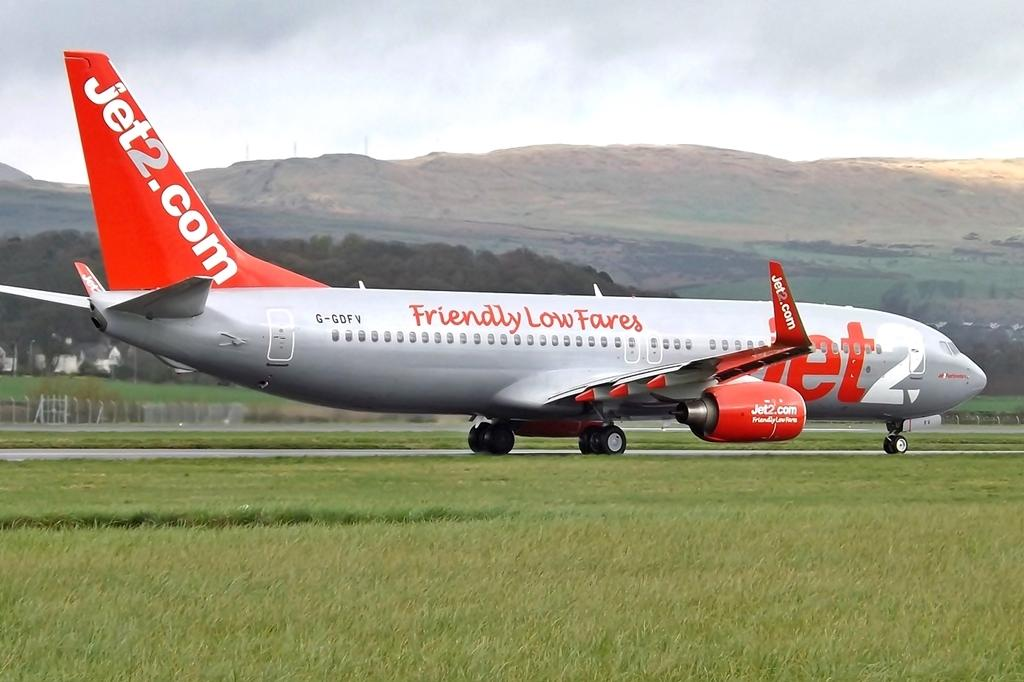<image>
Give a short and clear explanation of the subsequent image. Jet2.com planes advertise Friendly Low Fares on the fuselage. 